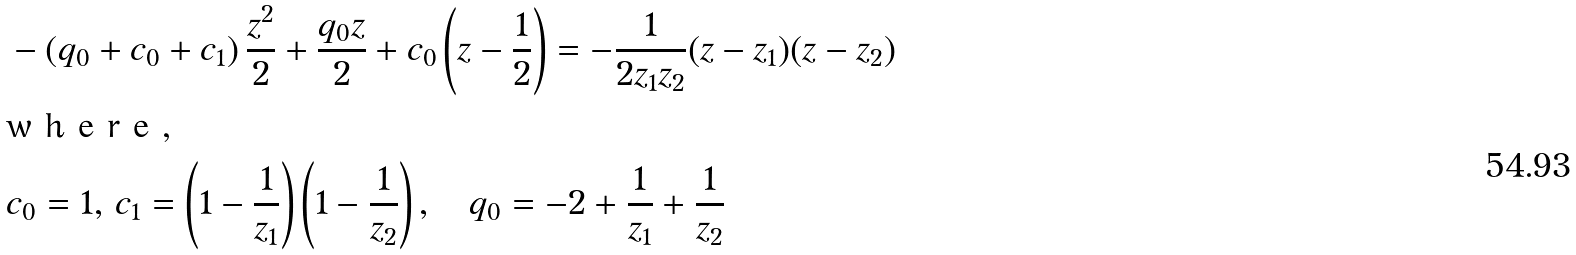<formula> <loc_0><loc_0><loc_500><loc_500>& - \left ( q _ { 0 } + c _ { 0 } + c _ { 1 } \right ) \frac { z ^ { 2 } } { 2 } + \frac { q _ { 0 } z } { 2 } + c _ { 0 } \left ( z - \frac { 1 } { 2 } \right ) = - \frac { 1 } { 2 z _ { 1 } z _ { 2 } } ( z - z _ { 1 } ) ( z - z _ { 2 } ) \intertext { w h e r e , } & c _ { 0 } = 1 , \, c _ { 1 } = \left ( 1 - \frac { 1 } { z _ { 1 } } \right ) \left ( 1 - \frac { 1 } { z _ { 2 } } \right ) , \quad q _ { 0 } = - 2 + \frac { 1 } { z _ { 1 } } + \frac { 1 } { z _ { 2 } }</formula> 